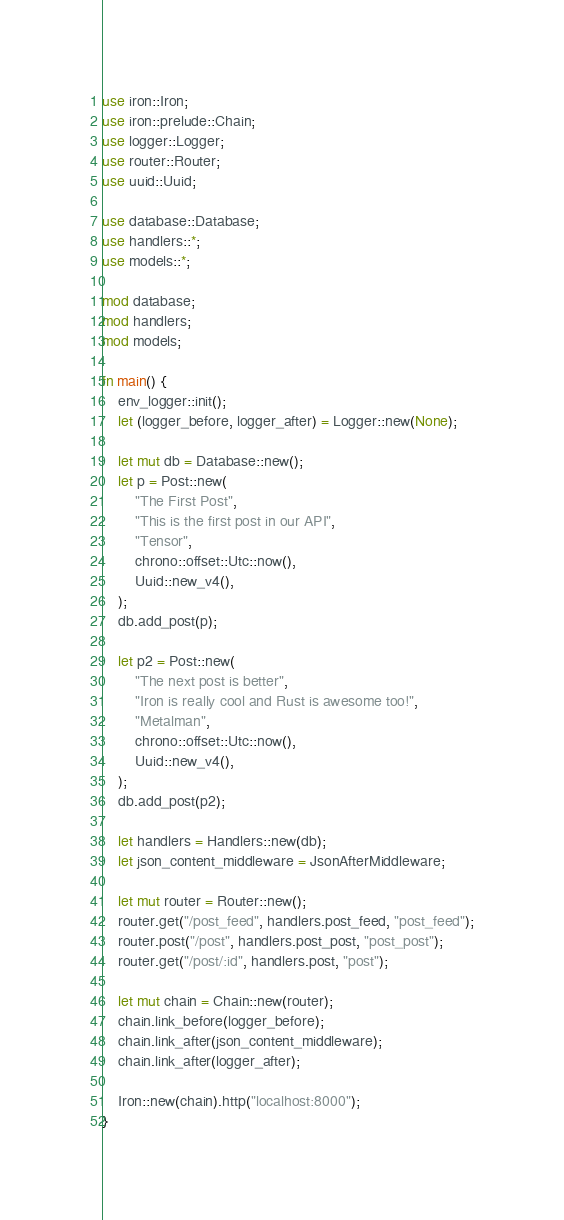<code> <loc_0><loc_0><loc_500><loc_500><_Rust_>use iron::Iron;
use iron::prelude::Chain;
use logger::Logger;
use router::Router;
use uuid::Uuid;

use database::Database;
use handlers::*;
use models::*;

mod database;
mod handlers;
mod models;

fn main() {
    env_logger::init();
    let (logger_before, logger_after) = Logger::new(None);

    let mut db = Database::new();
    let p = Post::new(
        "The First Post",
        "This is the first post in our API",
        "Tensor",
        chrono::offset::Utc::now(),
        Uuid::new_v4(),
    );
    db.add_post(p);

    let p2 = Post::new(
        "The next post is better",
        "Iron is really cool and Rust is awesome too!",
        "Metalman",
        chrono::offset::Utc::now(),
        Uuid::new_v4(),
    );
    db.add_post(p2);

    let handlers = Handlers::new(db);
    let json_content_middleware = JsonAfterMiddleware;

    let mut router = Router::new();
    router.get("/post_feed", handlers.post_feed, "post_feed");
    router.post("/post", handlers.post_post, "post_post");
    router.get("/post/:id", handlers.post, "post");

    let mut chain = Chain::new(router);
    chain.link_before(logger_before);
    chain.link_after(json_content_middleware);
    chain.link_after(logger_after);

    Iron::new(chain).http("localhost:8000");
}
</code> 